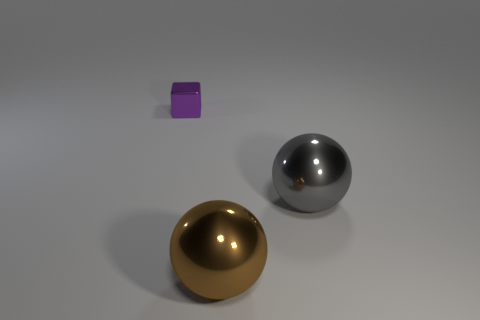Add 3 tiny blue rubber cylinders. How many objects exist? 6 Subtract all brown balls. How many balls are left? 1 Subtract all balls. How many objects are left? 1 Subtract all green cylinders. How many brown balls are left? 1 Add 3 gray metallic things. How many gray metallic things are left? 4 Add 2 gray metallic objects. How many gray metallic objects exist? 3 Subtract 1 gray spheres. How many objects are left? 2 Subtract all blue balls. Subtract all red cylinders. How many balls are left? 2 Subtract all big brown shiny objects. Subtract all large brown metal cylinders. How many objects are left? 2 